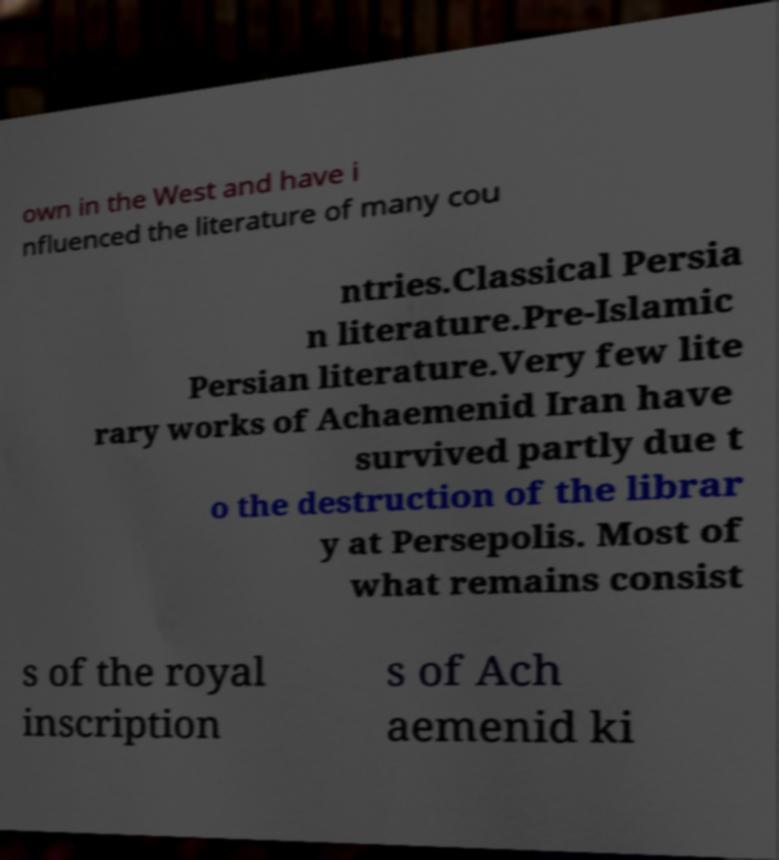Please identify and transcribe the text found in this image. own in the West and have i nfluenced the literature of many cou ntries.Classical Persia n literature.Pre-Islamic Persian literature.Very few lite rary works of Achaemenid Iran have survived partly due t o the destruction of the librar y at Persepolis. Most of what remains consist s of the royal inscription s of Ach aemenid ki 